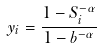Convert formula to latex. <formula><loc_0><loc_0><loc_500><loc_500>y _ { i } = \frac { 1 - S _ { i } ^ { - \alpha } } { 1 - b ^ { - \alpha } }</formula> 